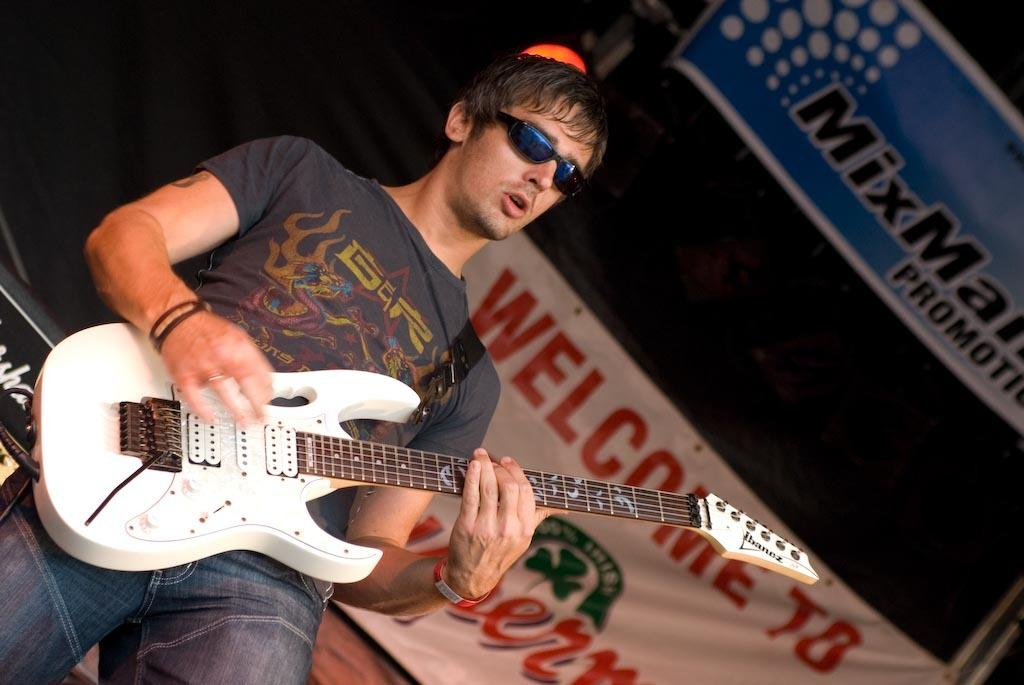What is the man in the image doing? The man is playing a guitar in the image. What is the man wearing while playing the guitar? The man is wearing goggles in the image. What can be seen in the background of the image? There is a banner in the background of the image. What type of jewel is the tramp wearing in the image? There is no tramp or jewel present in the image. What role does the actor play in the image? There is no actor present in the image. 